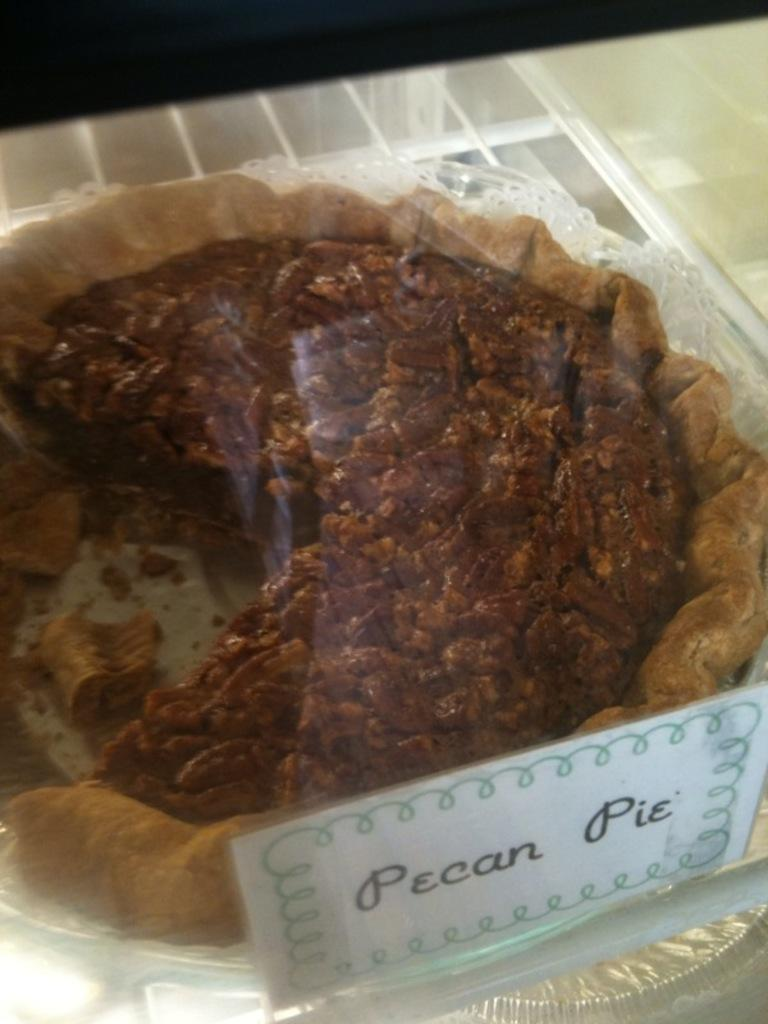What object is present in the image that is typically used for drinking? There is a glass in the image. What is covering the glass in the image? There is a paper pasted on the glass. What can be seen through the glass in the image? A pecan pie is visible through the glass. What type of insect can be seen crawling on the pecan pie in the image? There are no insects visible in the image; only a pecan pie can be seen through the glass. 